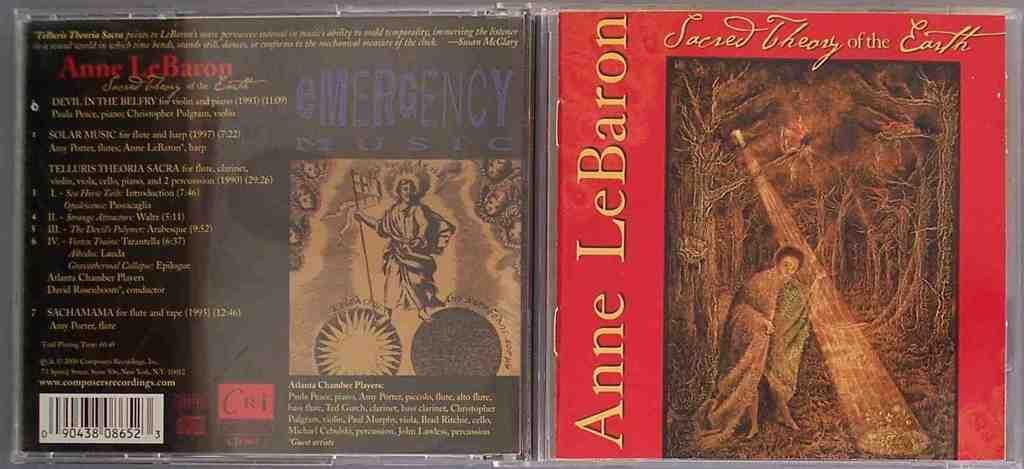<image>
Share a concise interpretation of the image provided. Two CD covers with one by Anne LeBaron. 